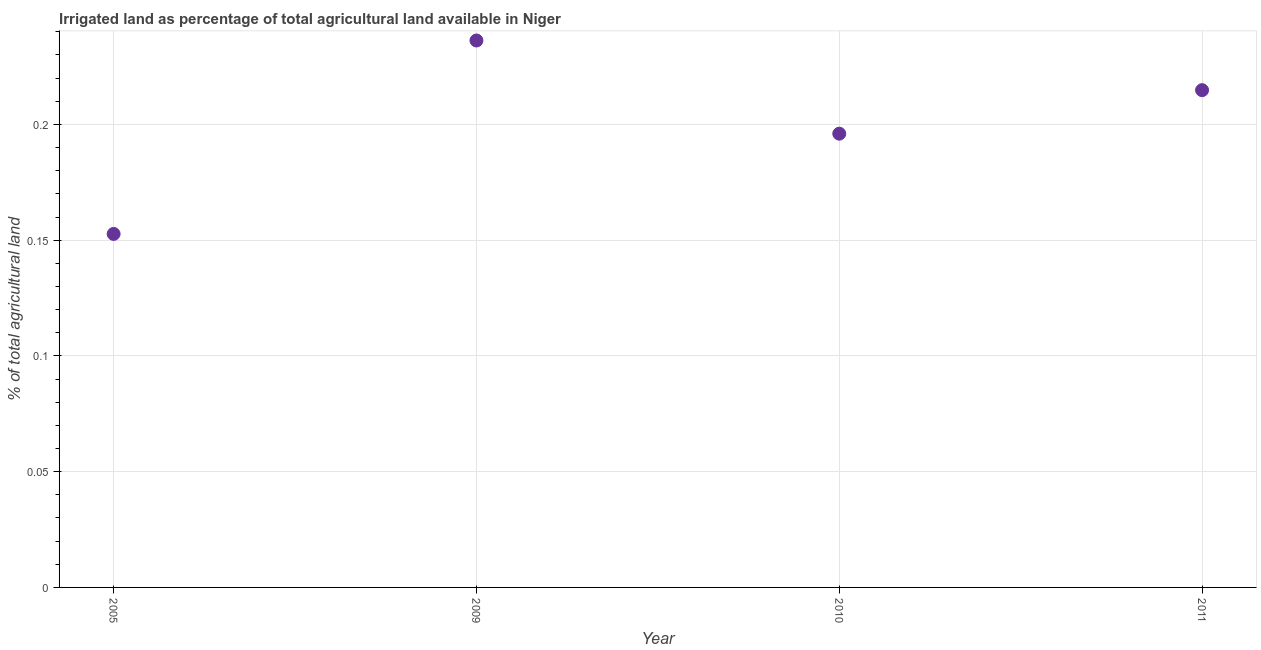What is the percentage of agricultural irrigated land in 2005?
Offer a terse response. 0.15. Across all years, what is the maximum percentage of agricultural irrigated land?
Your answer should be very brief. 0.24. Across all years, what is the minimum percentage of agricultural irrigated land?
Make the answer very short. 0.15. In which year was the percentage of agricultural irrigated land minimum?
Provide a short and direct response. 2005. What is the sum of the percentage of agricultural irrigated land?
Give a very brief answer. 0.8. What is the difference between the percentage of agricultural irrigated land in 2005 and 2009?
Provide a short and direct response. -0.08. What is the average percentage of agricultural irrigated land per year?
Ensure brevity in your answer.  0.2. What is the median percentage of agricultural irrigated land?
Ensure brevity in your answer.  0.21. In how many years, is the percentage of agricultural irrigated land greater than 0.12000000000000001 %?
Ensure brevity in your answer.  4. Do a majority of the years between 2011 and 2010 (inclusive) have percentage of agricultural irrigated land greater than 0.2 %?
Make the answer very short. No. What is the ratio of the percentage of agricultural irrigated land in 2010 to that in 2011?
Make the answer very short. 0.91. Is the percentage of agricultural irrigated land in 2010 less than that in 2011?
Offer a very short reply. Yes. Is the difference between the percentage of agricultural irrigated land in 2005 and 2009 greater than the difference between any two years?
Make the answer very short. Yes. What is the difference between the highest and the second highest percentage of agricultural irrigated land?
Offer a terse response. 0.02. What is the difference between the highest and the lowest percentage of agricultural irrigated land?
Your answer should be compact. 0.08. Does the percentage of agricultural irrigated land monotonically increase over the years?
Offer a very short reply. No. How many years are there in the graph?
Keep it short and to the point. 4. What is the difference between two consecutive major ticks on the Y-axis?
Provide a short and direct response. 0.05. What is the title of the graph?
Provide a succinct answer. Irrigated land as percentage of total agricultural land available in Niger. What is the label or title of the Y-axis?
Your answer should be compact. % of total agricultural land. What is the % of total agricultural land in 2005?
Give a very brief answer. 0.15. What is the % of total agricultural land in 2009?
Make the answer very short. 0.24. What is the % of total agricultural land in 2010?
Keep it short and to the point. 0.2. What is the % of total agricultural land in 2011?
Provide a succinct answer. 0.21. What is the difference between the % of total agricultural land in 2005 and 2009?
Offer a terse response. -0.08. What is the difference between the % of total agricultural land in 2005 and 2010?
Give a very brief answer. -0.04. What is the difference between the % of total agricultural land in 2005 and 2011?
Make the answer very short. -0.06. What is the difference between the % of total agricultural land in 2009 and 2010?
Your response must be concise. 0.04. What is the difference between the % of total agricultural land in 2009 and 2011?
Your response must be concise. 0.02. What is the difference between the % of total agricultural land in 2010 and 2011?
Your response must be concise. -0.02. What is the ratio of the % of total agricultural land in 2005 to that in 2009?
Give a very brief answer. 0.65. What is the ratio of the % of total agricultural land in 2005 to that in 2010?
Ensure brevity in your answer.  0.78. What is the ratio of the % of total agricultural land in 2005 to that in 2011?
Offer a terse response. 0.71. What is the ratio of the % of total agricultural land in 2009 to that in 2010?
Keep it short and to the point. 1.21. What is the ratio of the % of total agricultural land in 2010 to that in 2011?
Provide a succinct answer. 0.91. 